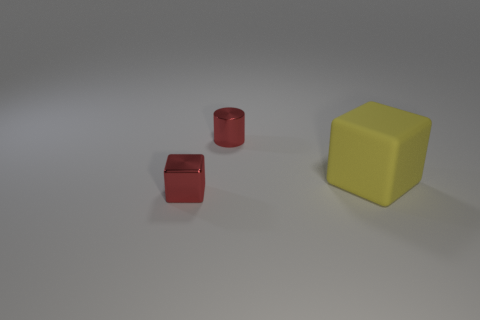Add 2 gray metallic blocks. How many objects exist? 5 Subtract all blocks. How many objects are left? 1 Add 2 matte blocks. How many matte blocks are left? 3 Add 1 red shiny blocks. How many red shiny blocks exist? 2 Subtract 0 yellow spheres. How many objects are left? 3 Subtract all tiny red metal cylinders. Subtract all cylinders. How many objects are left? 1 